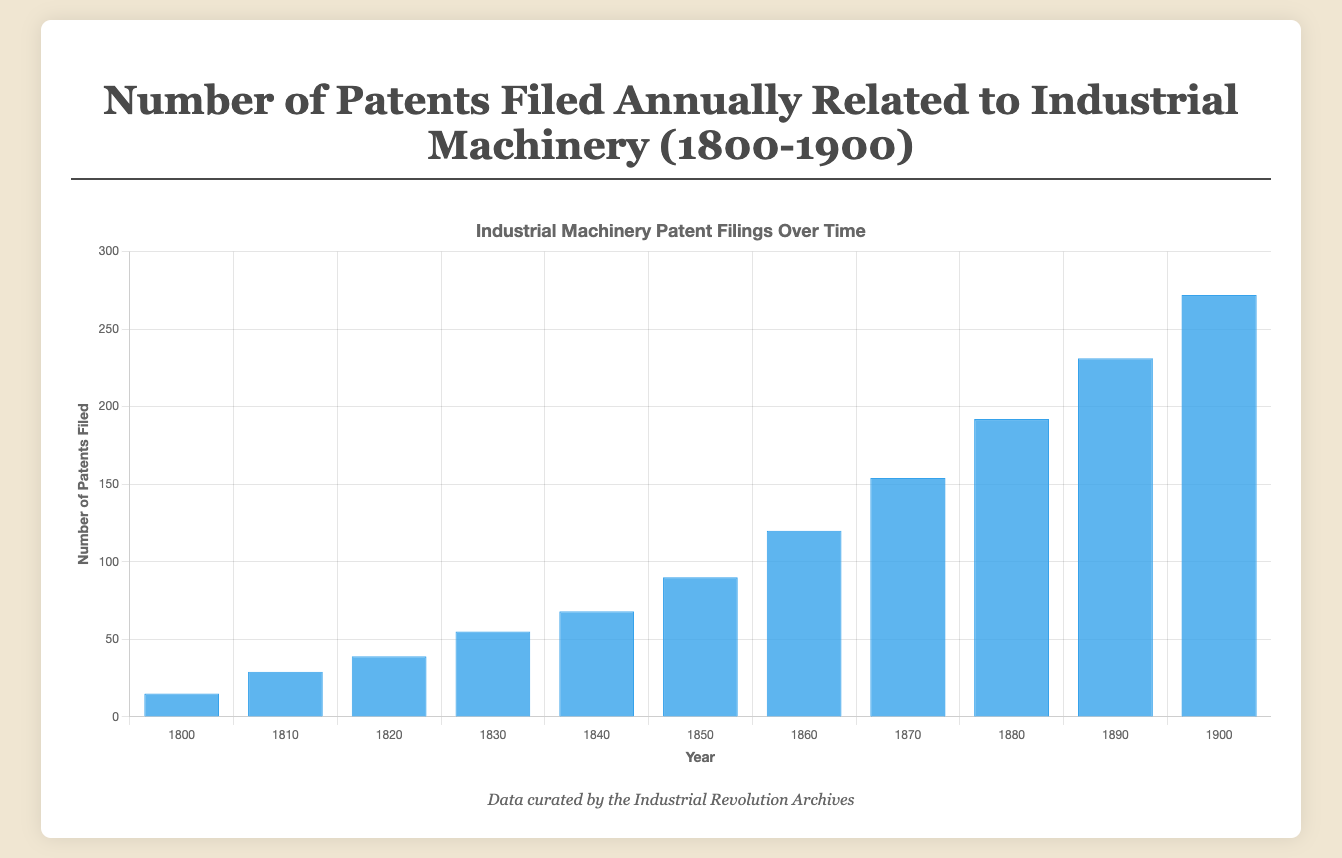What's the average number of patents filed every decade? Calculate the total number of patents filed for each decade and then divide by 10 for each period. For example, for 1800s: (15 + 19 + 22 + 18 + 25 + 21 + 27 + 20 + 23 + 31) / 10 = 22.1. Repeat for the other decades and then average the results.
Answer: Approximately 136.4 In which decade did the number of patents filed see the highest increase compared to the previous decade? Compare the total number of patents filed for each decade to the preceding decade. For instance, from 1800 to 1810: total for 1800s is 221 and for 1810s is 404, giving an increase of 183. Calculate for all decades and find which one has the highest increase.
Answer: 1870s to 1880s Which year had the highest number of patents filed, and how many were filed? Observe the bar heights and identify the year with the tallest blue bar, which corresponds to the highest number of patents filed.
Answer: 1900, 272 patents Between 1850 and 1860, in which year were the most patents filed? Look at the bar lengths from 1850 to 1860 and identify the year with the highest bar.
Answer: 1860 How many more patents were filed in 1900 than in 1800? Subtract the number of patents filed in 1800 from the number of patents filed in 1900: 272 - 15.
Answer: 257 